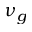Convert formula to latex. <formula><loc_0><loc_0><loc_500><loc_500>\nu _ { g }</formula> 